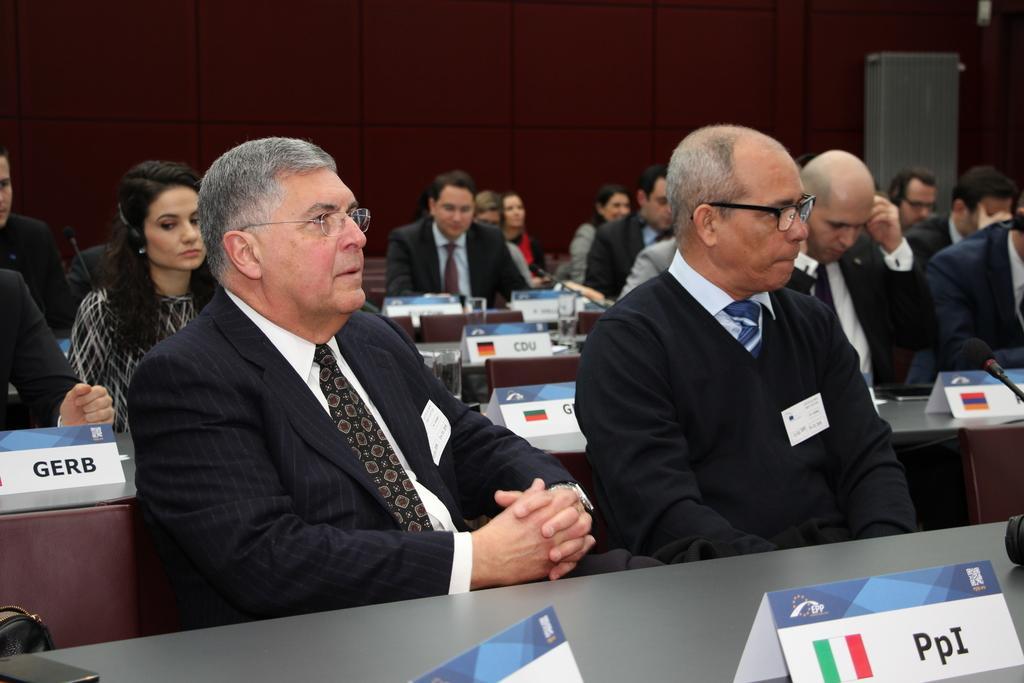In one or two sentences, can you explain what this image depicts? In this image, we can see there are persons in different color dresses, sitting in front of the tables, on which there are name boards, glasses and mics arranged. In the background, there is a gray color object. And the background is brown in color. 